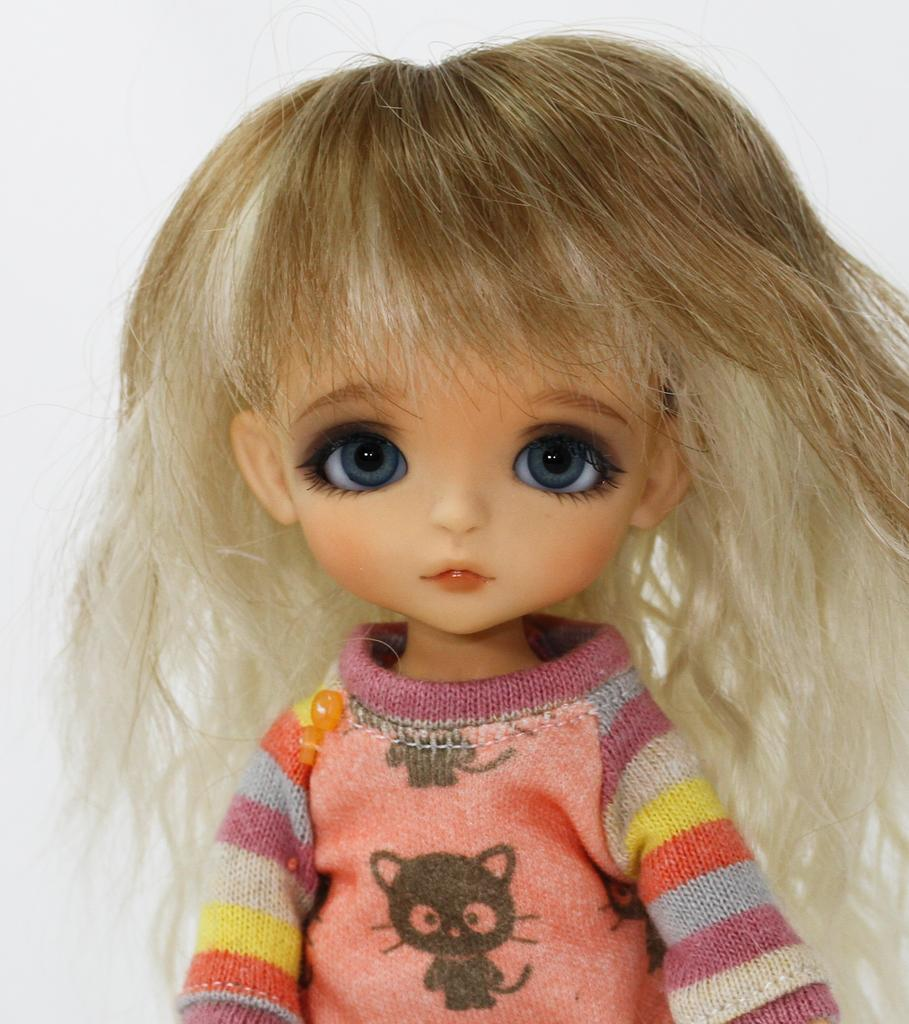What object is the main focus of the image? There is a toy in the image. What color is the background of the image? The background of the image is white. Where is the toothbrush located in the image? There is no toothbrush present in the image. 